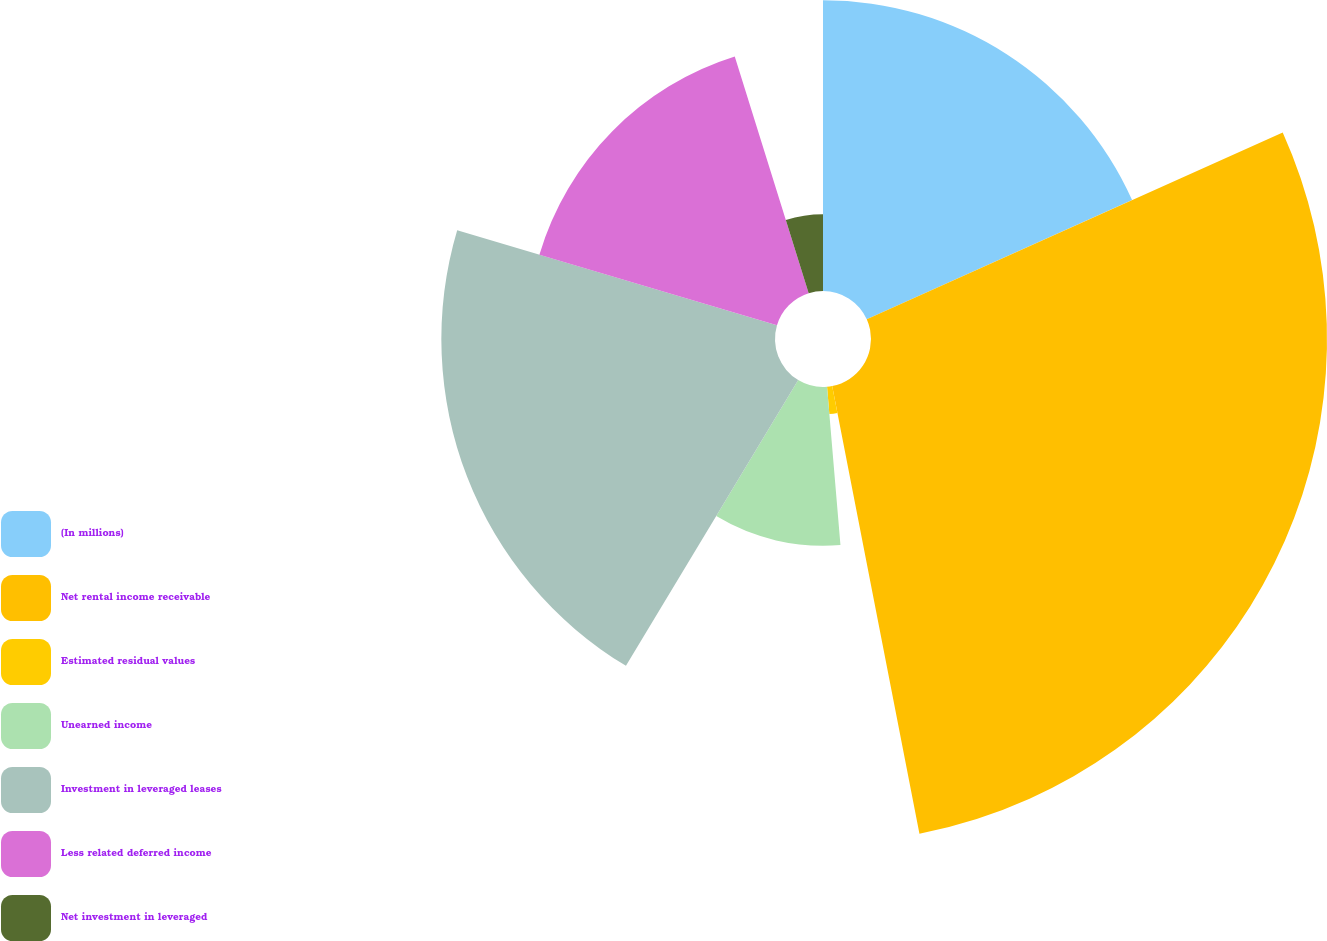Convert chart. <chart><loc_0><loc_0><loc_500><loc_500><pie_chart><fcel>(In millions)<fcel>Net rental income receivable<fcel>Estimated residual values<fcel>Unearned income<fcel>Investment in leveraged leases<fcel>Less related deferred income<fcel>Net investment in leveraged<nl><fcel>18.28%<fcel>28.66%<fcel>1.72%<fcel>9.98%<fcel>20.97%<fcel>15.58%<fcel>4.82%<nl></chart> 